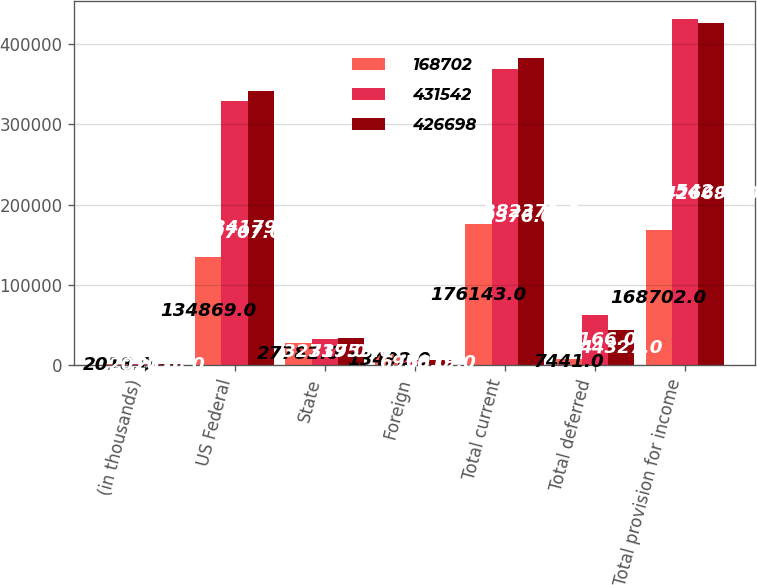Convert chart to OTSL. <chart><loc_0><loc_0><loc_500><loc_500><stacked_bar_chart><ecel><fcel>(in thousands)<fcel>US Federal<fcel>State<fcel>Foreign<fcel>Total current<fcel>Total deferred<fcel>Total provision for income<nl><fcel>168702<fcel>2018<fcel>134869<fcel>27782<fcel>13492<fcel>176143<fcel>7441<fcel>168702<nl><fcel>431542<fcel>2017<fcel>329707<fcel>32719<fcel>6950<fcel>369376<fcel>62166<fcel>431542<nl><fcel>426698<fcel>2016<fcel>341799<fcel>33753<fcel>6819<fcel>382371<fcel>44327<fcel>426698<nl></chart> 